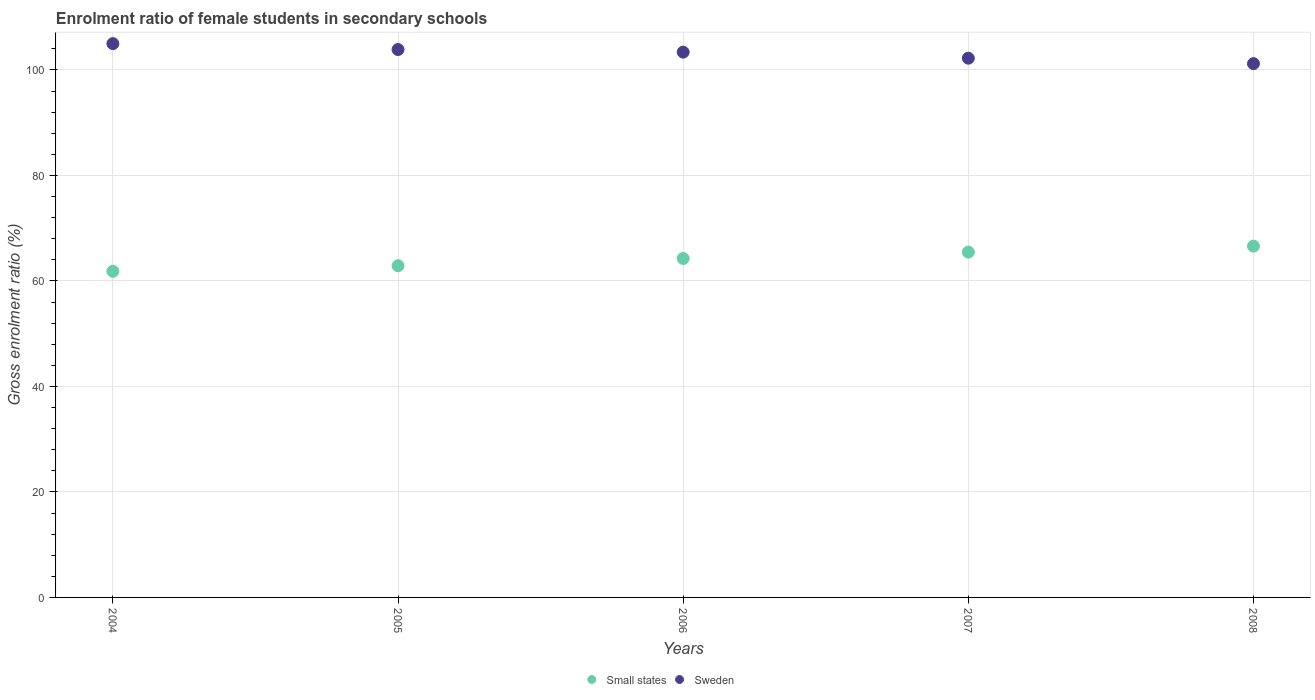Is the number of dotlines equal to the number of legend labels?
Offer a very short reply. Yes. What is the enrolment ratio of female students in secondary schools in Sweden in 2008?
Your response must be concise. 101.2. Across all years, what is the maximum enrolment ratio of female students in secondary schools in Sweden?
Offer a very short reply. 105. Across all years, what is the minimum enrolment ratio of female students in secondary schools in Small states?
Offer a terse response. 61.83. In which year was the enrolment ratio of female students in secondary schools in Small states maximum?
Provide a short and direct response. 2008. What is the total enrolment ratio of female students in secondary schools in Small states in the graph?
Give a very brief answer. 321.06. What is the difference between the enrolment ratio of female students in secondary schools in Small states in 2005 and that in 2007?
Give a very brief answer. -2.58. What is the difference between the enrolment ratio of female students in secondary schools in Small states in 2004 and the enrolment ratio of female students in secondary schools in Sweden in 2005?
Your response must be concise. -42.05. What is the average enrolment ratio of female students in secondary schools in Small states per year?
Give a very brief answer. 64.21. In the year 2005, what is the difference between the enrolment ratio of female students in secondary schools in Sweden and enrolment ratio of female students in secondary schools in Small states?
Make the answer very short. 40.99. In how many years, is the enrolment ratio of female students in secondary schools in Sweden greater than 28 %?
Ensure brevity in your answer.  5. What is the ratio of the enrolment ratio of female students in secondary schools in Sweden in 2007 to that in 2008?
Offer a terse response. 1.01. Is the enrolment ratio of female students in secondary schools in Sweden in 2007 less than that in 2008?
Your answer should be very brief. No. Is the difference between the enrolment ratio of female students in secondary schools in Sweden in 2006 and 2008 greater than the difference between the enrolment ratio of female students in secondary schools in Small states in 2006 and 2008?
Offer a very short reply. Yes. What is the difference between the highest and the second highest enrolment ratio of female students in secondary schools in Sweden?
Offer a very short reply. 1.12. What is the difference between the highest and the lowest enrolment ratio of female students in secondary schools in Small states?
Give a very brief answer. 4.78. How many dotlines are there?
Keep it short and to the point. 2. How many years are there in the graph?
Your answer should be compact. 5. What is the difference between two consecutive major ticks on the Y-axis?
Keep it short and to the point. 20. Are the values on the major ticks of Y-axis written in scientific E-notation?
Provide a succinct answer. No. Does the graph contain any zero values?
Offer a terse response. No. Does the graph contain grids?
Give a very brief answer. Yes. Where does the legend appear in the graph?
Offer a terse response. Bottom center. How many legend labels are there?
Provide a short and direct response. 2. What is the title of the graph?
Offer a very short reply. Enrolment ratio of female students in secondary schools. What is the label or title of the X-axis?
Keep it short and to the point. Years. What is the Gross enrolment ratio (%) in Small states in 2004?
Your response must be concise. 61.83. What is the Gross enrolment ratio (%) in Sweden in 2004?
Provide a succinct answer. 105. What is the Gross enrolment ratio (%) in Small states in 2005?
Provide a short and direct response. 62.89. What is the Gross enrolment ratio (%) in Sweden in 2005?
Provide a short and direct response. 103.88. What is the Gross enrolment ratio (%) in Small states in 2006?
Your answer should be very brief. 64.27. What is the Gross enrolment ratio (%) in Sweden in 2006?
Offer a very short reply. 103.39. What is the Gross enrolment ratio (%) of Small states in 2007?
Provide a short and direct response. 65.47. What is the Gross enrolment ratio (%) in Sweden in 2007?
Offer a terse response. 102.24. What is the Gross enrolment ratio (%) in Small states in 2008?
Offer a very short reply. 66.61. What is the Gross enrolment ratio (%) in Sweden in 2008?
Ensure brevity in your answer.  101.2. Across all years, what is the maximum Gross enrolment ratio (%) of Small states?
Your answer should be compact. 66.61. Across all years, what is the maximum Gross enrolment ratio (%) of Sweden?
Make the answer very short. 105. Across all years, what is the minimum Gross enrolment ratio (%) of Small states?
Provide a short and direct response. 61.83. Across all years, what is the minimum Gross enrolment ratio (%) of Sweden?
Keep it short and to the point. 101.2. What is the total Gross enrolment ratio (%) in Small states in the graph?
Provide a short and direct response. 321.06. What is the total Gross enrolment ratio (%) in Sweden in the graph?
Give a very brief answer. 515.71. What is the difference between the Gross enrolment ratio (%) in Small states in 2004 and that in 2005?
Provide a short and direct response. -1.06. What is the difference between the Gross enrolment ratio (%) in Sweden in 2004 and that in 2005?
Your answer should be compact. 1.12. What is the difference between the Gross enrolment ratio (%) in Small states in 2004 and that in 2006?
Offer a terse response. -2.44. What is the difference between the Gross enrolment ratio (%) of Sweden in 2004 and that in 2006?
Offer a terse response. 1.61. What is the difference between the Gross enrolment ratio (%) in Small states in 2004 and that in 2007?
Give a very brief answer. -3.64. What is the difference between the Gross enrolment ratio (%) in Sweden in 2004 and that in 2007?
Make the answer very short. 2.76. What is the difference between the Gross enrolment ratio (%) in Small states in 2004 and that in 2008?
Ensure brevity in your answer.  -4.78. What is the difference between the Gross enrolment ratio (%) of Sweden in 2004 and that in 2008?
Offer a terse response. 3.79. What is the difference between the Gross enrolment ratio (%) in Small states in 2005 and that in 2006?
Provide a short and direct response. -1.38. What is the difference between the Gross enrolment ratio (%) of Sweden in 2005 and that in 2006?
Offer a very short reply. 0.49. What is the difference between the Gross enrolment ratio (%) in Small states in 2005 and that in 2007?
Make the answer very short. -2.58. What is the difference between the Gross enrolment ratio (%) of Sweden in 2005 and that in 2007?
Your response must be concise. 1.64. What is the difference between the Gross enrolment ratio (%) in Small states in 2005 and that in 2008?
Your response must be concise. -3.72. What is the difference between the Gross enrolment ratio (%) in Sweden in 2005 and that in 2008?
Provide a succinct answer. 2.67. What is the difference between the Gross enrolment ratio (%) of Small states in 2006 and that in 2007?
Offer a very short reply. -1.2. What is the difference between the Gross enrolment ratio (%) in Sweden in 2006 and that in 2007?
Your response must be concise. 1.15. What is the difference between the Gross enrolment ratio (%) of Small states in 2006 and that in 2008?
Ensure brevity in your answer.  -2.34. What is the difference between the Gross enrolment ratio (%) of Sweden in 2006 and that in 2008?
Provide a succinct answer. 2.18. What is the difference between the Gross enrolment ratio (%) of Small states in 2007 and that in 2008?
Your response must be concise. -1.14. What is the difference between the Gross enrolment ratio (%) in Sweden in 2007 and that in 2008?
Keep it short and to the point. 1.03. What is the difference between the Gross enrolment ratio (%) of Small states in 2004 and the Gross enrolment ratio (%) of Sweden in 2005?
Give a very brief answer. -42.05. What is the difference between the Gross enrolment ratio (%) in Small states in 2004 and the Gross enrolment ratio (%) in Sweden in 2006?
Provide a short and direct response. -41.56. What is the difference between the Gross enrolment ratio (%) of Small states in 2004 and the Gross enrolment ratio (%) of Sweden in 2007?
Offer a terse response. -40.41. What is the difference between the Gross enrolment ratio (%) in Small states in 2004 and the Gross enrolment ratio (%) in Sweden in 2008?
Provide a succinct answer. -39.38. What is the difference between the Gross enrolment ratio (%) in Small states in 2005 and the Gross enrolment ratio (%) in Sweden in 2006?
Provide a short and direct response. -40.5. What is the difference between the Gross enrolment ratio (%) in Small states in 2005 and the Gross enrolment ratio (%) in Sweden in 2007?
Ensure brevity in your answer.  -39.35. What is the difference between the Gross enrolment ratio (%) in Small states in 2005 and the Gross enrolment ratio (%) in Sweden in 2008?
Give a very brief answer. -38.32. What is the difference between the Gross enrolment ratio (%) of Small states in 2006 and the Gross enrolment ratio (%) of Sweden in 2007?
Offer a terse response. -37.97. What is the difference between the Gross enrolment ratio (%) in Small states in 2006 and the Gross enrolment ratio (%) in Sweden in 2008?
Offer a terse response. -36.94. What is the difference between the Gross enrolment ratio (%) of Small states in 2007 and the Gross enrolment ratio (%) of Sweden in 2008?
Offer a very short reply. -35.74. What is the average Gross enrolment ratio (%) in Small states per year?
Give a very brief answer. 64.21. What is the average Gross enrolment ratio (%) in Sweden per year?
Offer a terse response. 103.14. In the year 2004, what is the difference between the Gross enrolment ratio (%) of Small states and Gross enrolment ratio (%) of Sweden?
Ensure brevity in your answer.  -43.17. In the year 2005, what is the difference between the Gross enrolment ratio (%) of Small states and Gross enrolment ratio (%) of Sweden?
Give a very brief answer. -40.99. In the year 2006, what is the difference between the Gross enrolment ratio (%) in Small states and Gross enrolment ratio (%) in Sweden?
Your response must be concise. -39.12. In the year 2007, what is the difference between the Gross enrolment ratio (%) of Small states and Gross enrolment ratio (%) of Sweden?
Offer a very short reply. -36.77. In the year 2008, what is the difference between the Gross enrolment ratio (%) in Small states and Gross enrolment ratio (%) in Sweden?
Provide a succinct answer. -34.59. What is the ratio of the Gross enrolment ratio (%) in Small states in 2004 to that in 2005?
Offer a terse response. 0.98. What is the ratio of the Gross enrolment ratio (%) of Sweden in 2004 to that in 2005?
Keep it short and to the point. 1.01. What is the ratio of the Gross enrolment ratio (%) in Small states in 2004 to that in 2006?
Ensure brevity in your answer.  0.96. What is the ratio of the Gross enrolment ratio (%) of Sweden in 2004 to that in 2006?
Ensure brevity in your answer.  1.02. What is the ratio of the Gross enrolment ratio (%) of Small states in 2004 to that in 2007?
Your answer should be compact. 0.94. What is the ratio of the Gross enrolment ratio (%) of Small states in 2004 to that in 2008?
Your answer should be very brief. 0.93. What is the ratio of the Gross enrolment ratio (%) of Sweden in 2004 to that in 2008?
Make the answer very short. 1.04. What is the ratio of the Gross enrolment ratio (%) in Small states in 2005 to that in 2006?
Keep it short and to the point. 0.98. What is the ratio of the Gross enrolment ratio (%) in Small states in 2005 to that in 2007?
Your answer should be compact. 0.96. What is the ratio of the Gross enrolment ratio (%) in Sweden in 2005 to that in 2007?
Make the answer very short. 1.02. What is the ratio of the Gross enrolment ratio (%) of Small states in 2005 to that in 2008?
Give a very brief answer. 0.94. What is the ratio of the Gross enrolment ratio (%) in Sweden in 2005 to that in 2008?
Offer a very short reply. 1.03. What is the ratio of the Gross enrolment ratio (%) in Small states in 2006 to that in 2007?
Provide a short and direct response. 0.98. What is the ratio of the Gross enrolment ratio (%) in Sweden in 2006 to that in 2007?
Your answer should be compact. 1.01. What is the ratio of the Gross enrolment ratio (%) in Small states in 2006 to that in 2008?
Offer a very short reply. 0.96. What is the ratio of the Gross enrolment ratio (%) of Sweden in 2006 to that in 2008?
Give a very brief answer. 1.02. What is the ratio of the Gross enrolment ratio (%) of Small states in 2007 to that in 2008?
Your answer should be very brief. 0.98. What is the ratio of the Gross enrolment ratio (%) in Sweden in 2007 to that in 2008?
Your answer should be compact. 1.01. What is the difference between the highest and the second highest Gross enrolment ratio (%) of Small states?
Give a very brief answer. 1.14. What is the difference between the highest and the second highest Gross enrolment ratio (%) in Sweden?
Provide a succinct answer. 1.12. What is the difference between the highest and the lowest Gross enrolment ratio (%) in Small states?
Ensure brevity in your answer.  4.78. What is the difference between the highest and the lowest Gross enrolment ratio (%) of Sweden?
Your response must be concise. 3.79. 